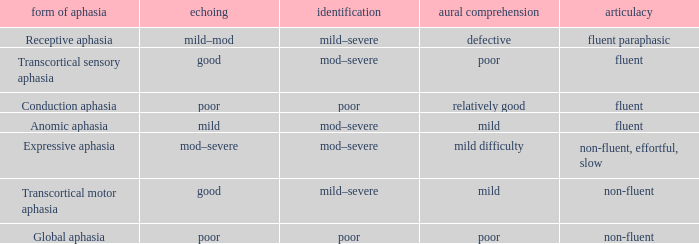Name the naming for fluent and poor comprehension Mod–severe. 